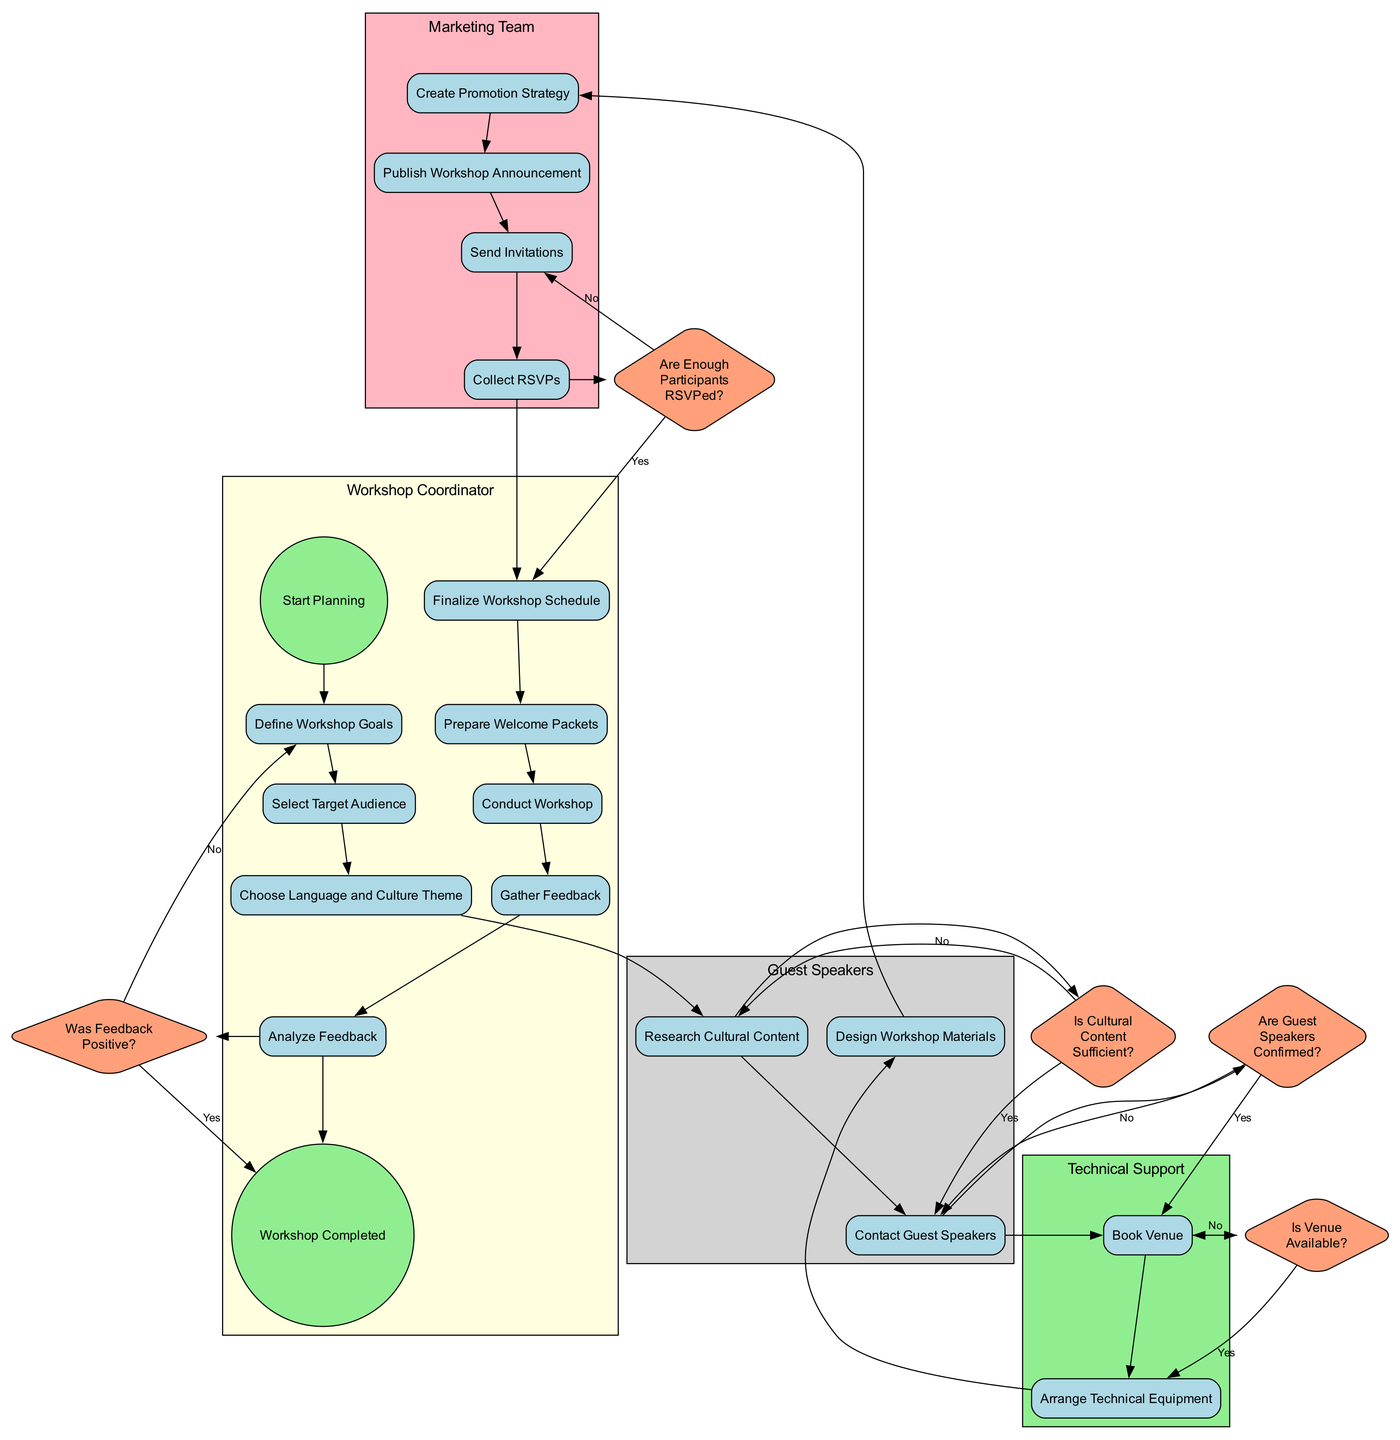What is the start event of the diagram? The start event is labeled as "Start Planning" which indicates the beginning of the process illustrated in the diagram.
Answer: Start Planning How many decision nodes are present in the diagram? The diagram features a total of five decision nodes, which include questions about the venue, guest speakers, cultural content, RSVPs, and feedback.
Answer: 5 What activity follows "Collect RSVPs"? After "Collect RSVPs," the next activity in the flow is "Finalize Workshop Schedule," indicating the progression towards scheduling the workshop.
Answer: Finalize Workshop Schedule Which team is responsible for creating the promotion strategy? The node labeled "Create Promotion Strategy" is under the swimlane indicating the "Marketing Team," which is responsible for this activity.
Answer: Marketing Team What happens if the venue is not available? If the venue is not available, the flow indicates that the process will return to the "Book Venue" activity; this is a decision point where "No" leads back to seeking another venue.
Answer: Book Venue How many activities are there in the "Workshop Coordinator" swimlane? The "Workshop Coordinator" swimlane contains eight activities: Define Workshop Goals, Select Target Audience, Choose Language and Culture Theme, Finalize Workshop Schedule, Prepare Welcome Packets, Conduct Workshop, Gather Feedback, and Analyze Feedback.
Answer: 8 What is the end event of the diagram? The end event is labeled as "Workshop Completed," marking the conclusion of the activities involved in organizing the workshop.
Answer: Workshop Completed What is the sequence of actions starting from "Design Workshop Materials"? Starting from "Design Workshop Materials," the sequence is: create strategy, publish announcement, send invitations, collect RSVPs, finalize schedule, prepare packets, conduct workshop, gather feedback, analyze feedback, ending at "Workshop Completed."
Answer: create strategy, publish announcement, send invitations, collect RSVPs, finalize schedule, prepare packets, conduct workshop, gather feedback, analyze feedback If there are not enough participants RSVPed, what activity is pursued next? If there are not enough participants RSVPed, the process directs back to the "Send Invitations" activity, implying that more invitations need to be sent to increase participation.
Answer: Send Invitations 